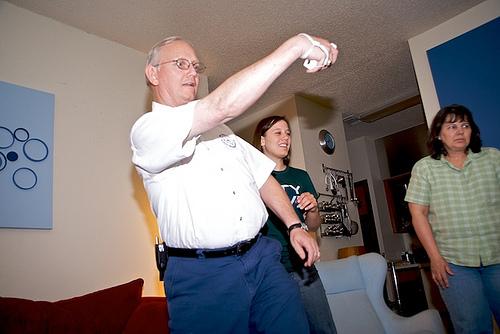What kind of game are these people playing?
Quick response, please. Wii. What color is the shirt of the woman closest to the front of the picture?
Keep it brief. Green. Do you think all the people here are playing the game?
Keep it brief. No. Is the woman in the back ignoring the others?
Give a very brief answer. No. Are these people having fun?
Quick response, please. Yes. Who is wearing the white shirt with Colorado on the front?
Concise answer only. Man. 